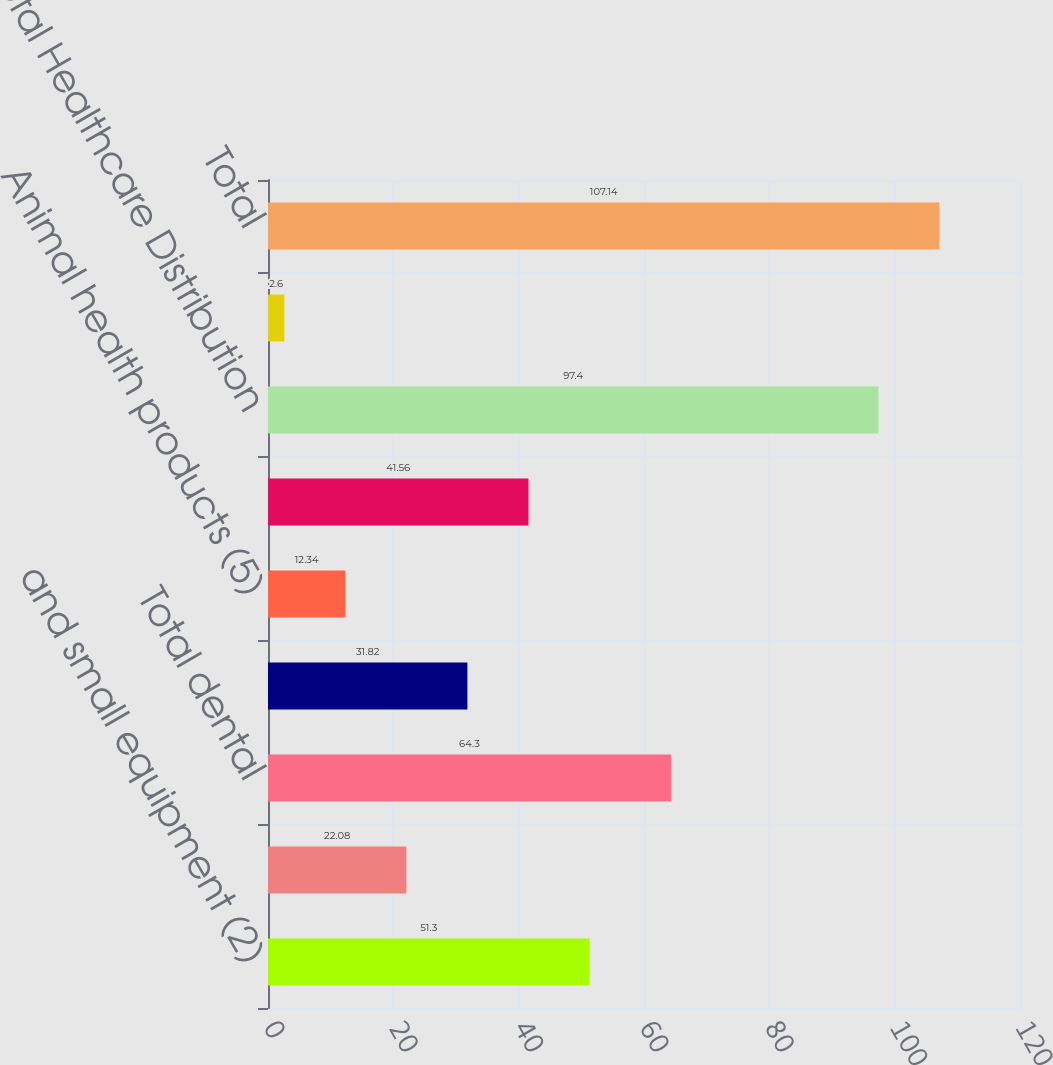Convert chart to OTSL. <chart><loc_0><loc_0><loc_500><loc_500><bar_chart><fcel>and small equipment (2)<fcel>Large dental equipment (3)<fcel>Total dental<fcel>Medical products (4)<fcel>Animal health products (5)<fcel>Total medical<fcel>Total Healthcare Distribution<fcel>other value-added products (6)<fcel>Total<nl><fcel>51.3<fcel>22.08<fcel>64.3<fcel>31.82<fcel>12.34<fcel>41.56<fcel>97.4<fcel>2.6<fcel>107.14<nl></chart> 